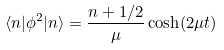Convert formula to latex. <formula><loc_0><loc_0><loc_500><loc_500>\langle n | \phi ^ { 2 } | n \rangle = \frac { n + 1 / 2 } { \mu } \cosh ( 2 \mu t )</formula> 